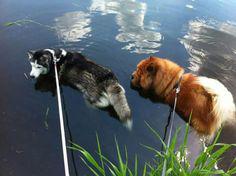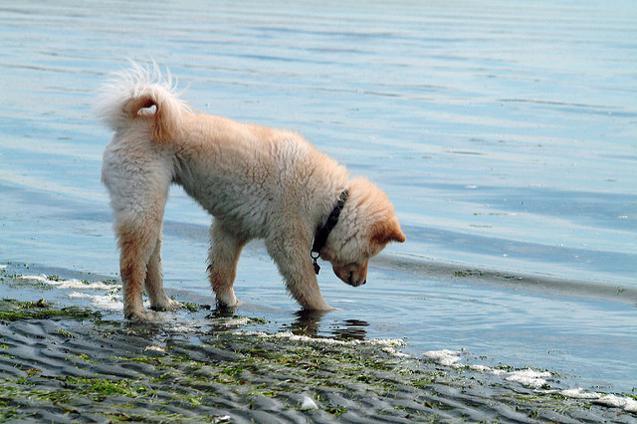The first image is the image on the left, the second image is the image on the right. Given the left and right images, does the statement "The left image contains exactly two dogs." hold true? Answer yes or no. Yes. The first image is the image on the left, the second image is the image on the right. For the images displayed, is the sentence "One dog in the image on the right is standing on a grassy area." factually correct? Answer yes or no. No. 